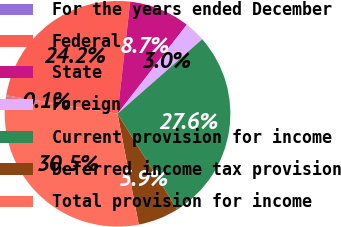Convert chart to OTSL. <chart><loc_0><loc_0><loc_500><loc_500><pie_chart><fcel>For the years ended December<fcel>Federal<fcel>State<fcel>Foreign<fcel>Current provision for income<fcel>Deferred income tax provision<fcel>Total provision for income<nl><fcel>0.13%<fcel>24.19%<fcel>8.73%<fcel>2.99%<fcel>27.62%<fcel>5.86%<fcel>30.49%<nl></chart> 